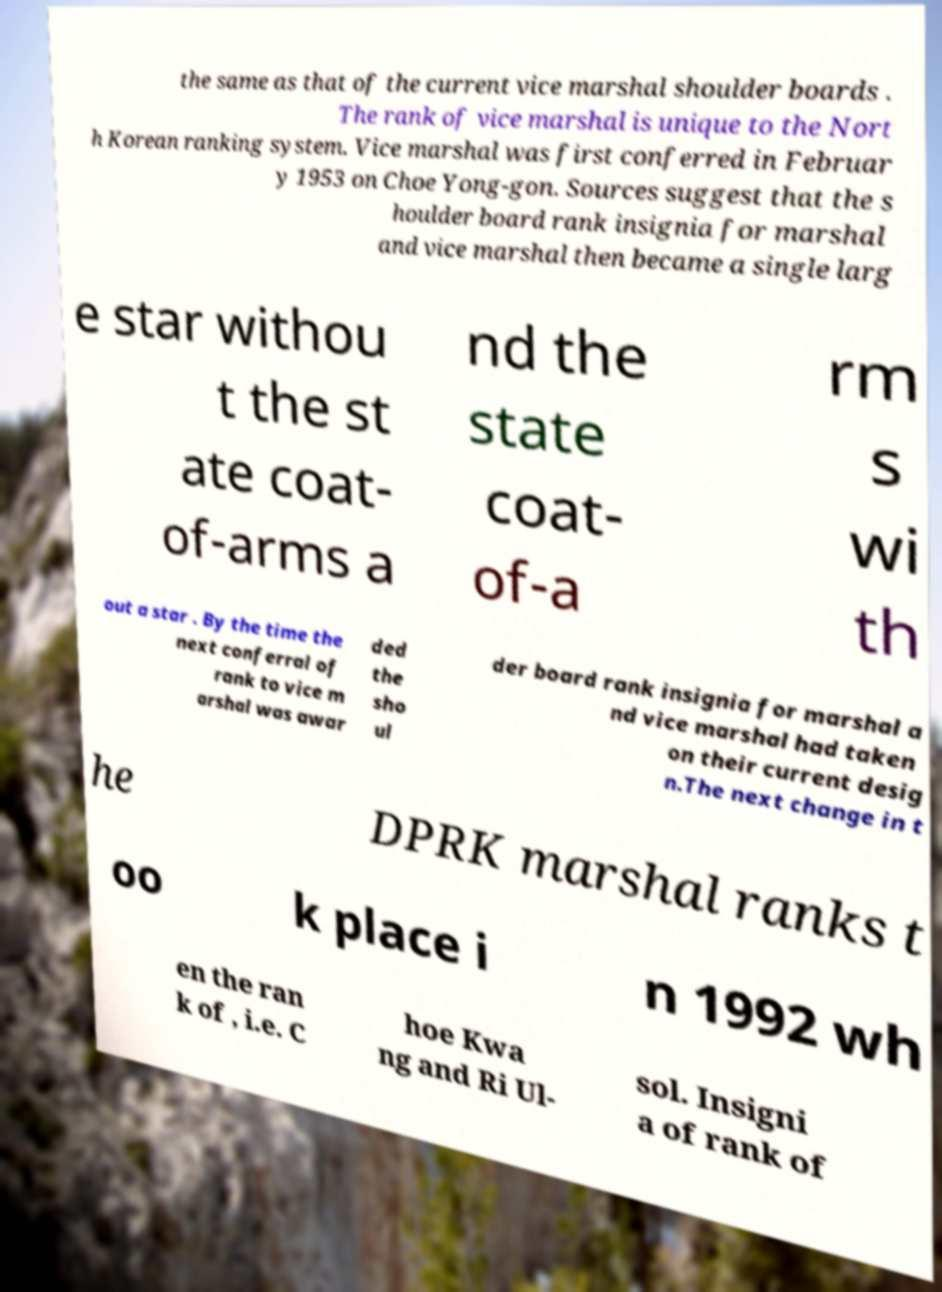Could you assist in decoding the text presented in this image and type it out clearly? the same as that of the current vice marshal shoulder boards . The rank of vice marshal is unique to the Nort h Korean ranking system. Vice marshal was first conferred in Februar y 1953 on Choe Yong-gon. Sources suggest that the s houlder board rank insignia for marshal and vice marshal then became a single larg e star withou t the st ate coat- of-arms a nd the state coat- of-a rm s wi th out a star . By the time the next conferral of rank to vice m arshal was awar ded the sho ul der board rank insignia for marshal a nd vice marshal had taken on their current desig n.The next change in t he DPRK marshal ranks t oo k place i n 1992 wh en the ran k of , i.e. C hoe Kwa ng and Ri Ul- sol. Insigni a of rank of 